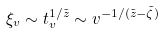<formula> <loc_0><loc_0><loc_500><loc_500>\xi _ { v } \sim t _ { v } ^ { 1 / \tilde { z } } \sim v ^ { - 1 / ( \tilde { z } - \tilde { \zeta } ) }</formula> 